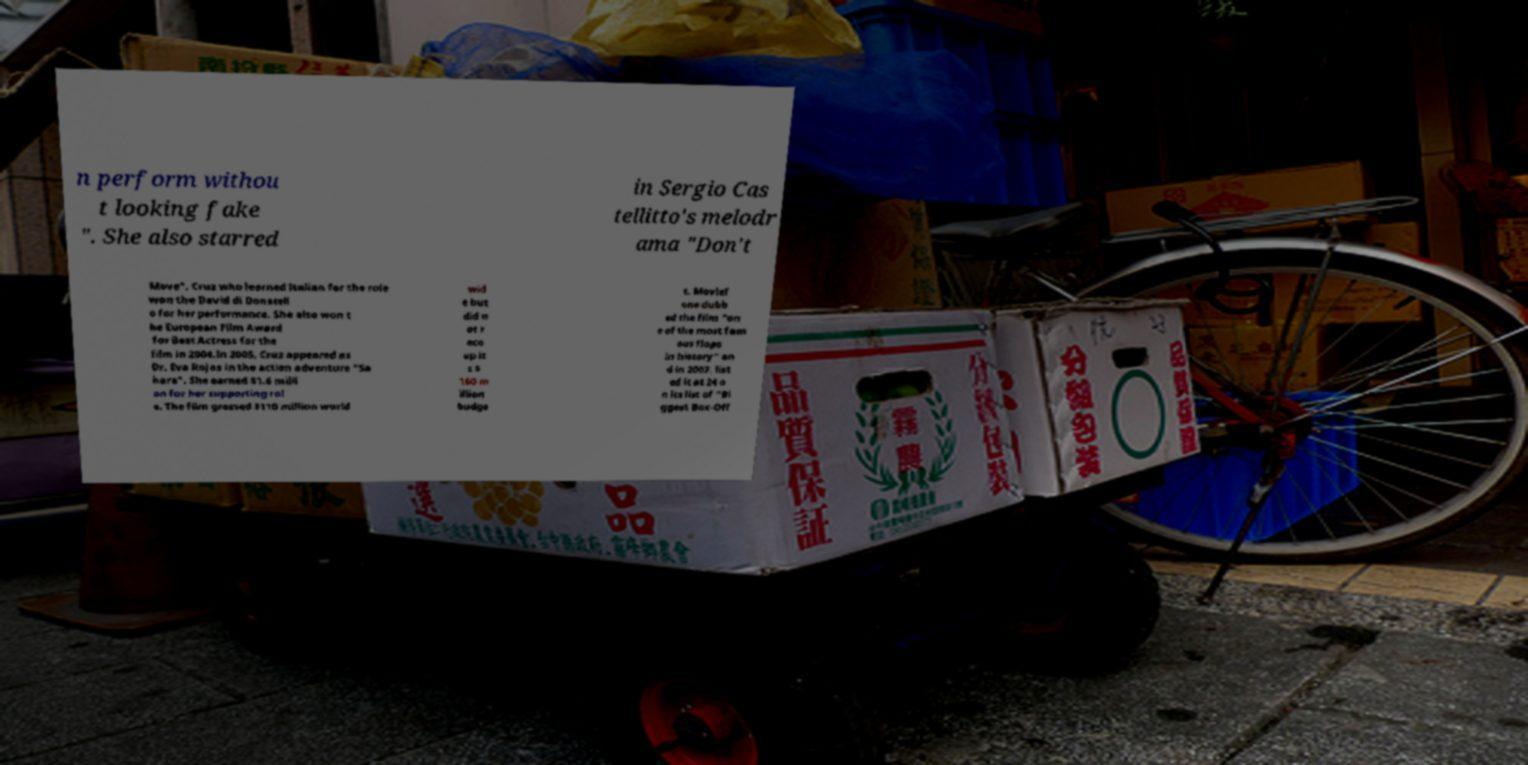For documentation purposes, I need the text within this image transcribed. Could you provide that? n perform withou t looking fake ". She also starred in Sergio Cas tellitto's melodr ama "Don't Move". Cruz who learned Italian for the role won the David di Donatell o for her performance. She also won t he European Film Award for Best Actress for the film in 2004.In 2005, Cruz appeared as Dr. Eva Rojas in the action adventure "Sa hara". She earned $1.6 milli on for her supporting rol e. The film grossed $110 million world wid e but did n ot r eco up it s $ 160 m illion budge t. Movief one dubb ed the film "on e of the most fam ous flops in history" an d in 2007, list ed it at 24 o n its list of "Bi ggest Box-Off 